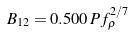<formula> <loc_0><loc_0><loc_500><loc_500>B _ { 1 2 } = 0 . 5 0 0 \, P f _ { \rho } ^ { 2 / 7 }</formula> 